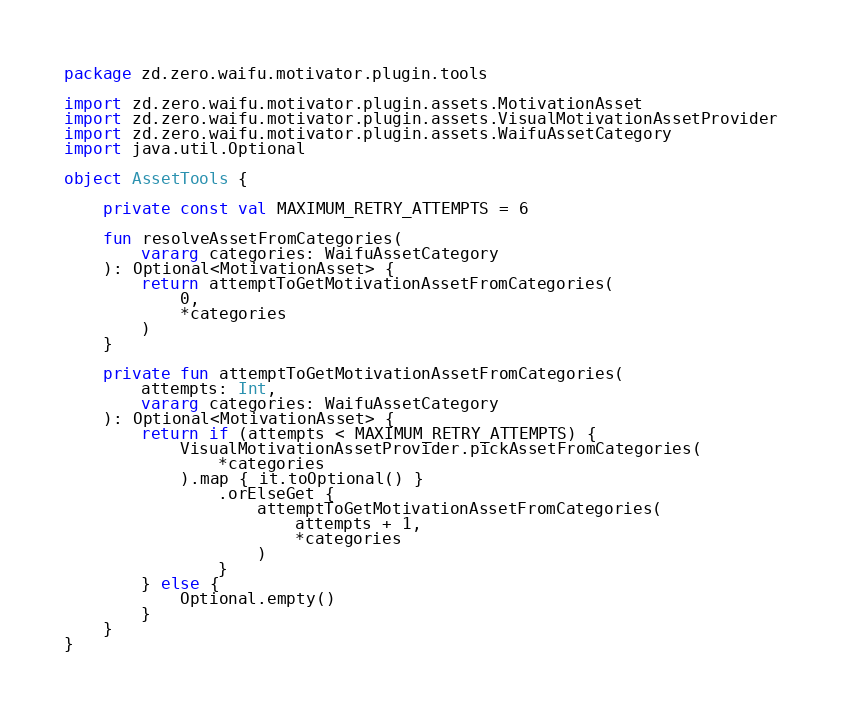<code> <loc_0><loc_0><loc_500><loc_500><_Kotlin_>package zd.zero.waifu.motivator.plugin.tools

import zd.zero.waifu.motivator.plugin.assets.MotivationAsset
import zd.zero.waifu.motivator.plugin.assets.VisualMotivationAssetProvider
import zd.zero.waifu.motivator.plugin.assets.WaifuAssetCategory
import java.util.Optional

object AssetTools {

    private const val MAXIMUM_RETRY_ATTEMPTS = 6

    fun resolveAssetFromCategories(
        vararg categories: WaifuAssetCategory
    ): Optional<MotivationAsset> {
        return attemptToGetMotivationAssetFromCategories(
            0,
            *categories
        )
    }

    private fun attemptToGetMotivationAssetFromCategories(
        attempts: Int,
        vararg categories: WaifuAssetCategory
    ): Optional<MotivationAsset> {
        return if (attempts < MAXIMUM_RETRY_ATTEMPTS) {
            VisualMotivationAssetProvider.pickAssetFromCategories(
                *categories
            ).map { it.toOptional() }
                .orElseGet {
                    attemptToGetMotivationAssetFromCategories(
                        attempts + 1,
                        *categories
                    )
                }
        } else {
            Optional.empty()
        }
    }
}
</code> 